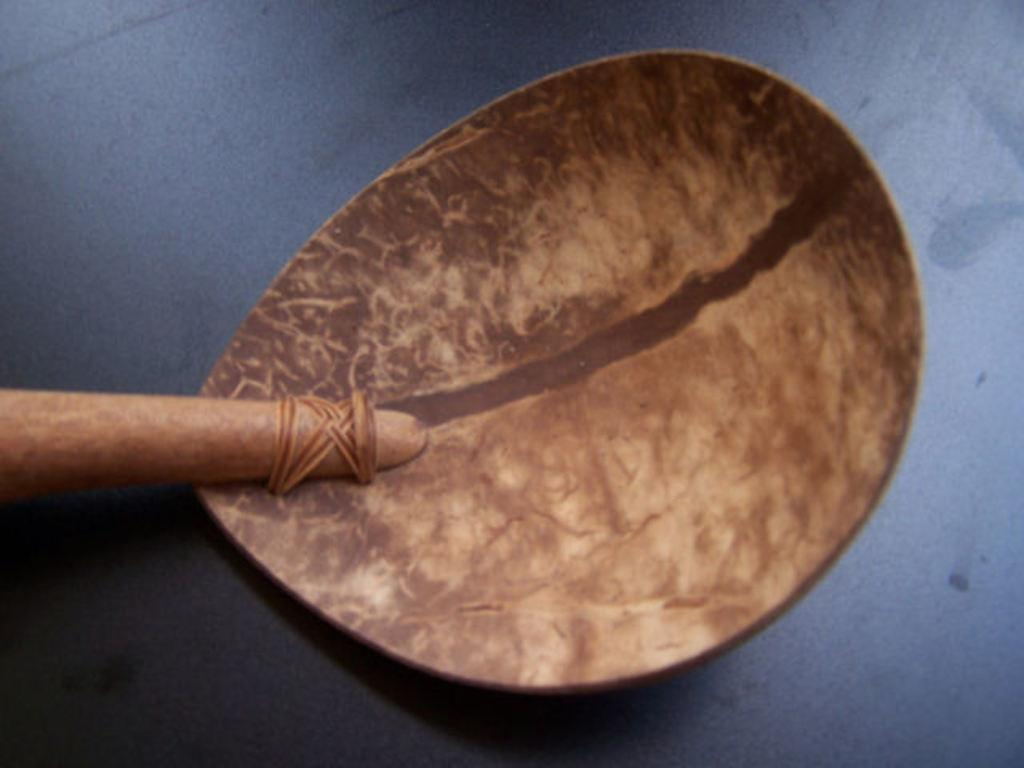What type of material is the artifact made of in the image? The wooden artifact is made of wood. Where is the wooden artifact located in the image? The wooden artifact is on the floor. What type of soup is being served in the wooden artifact in the image? There is no soup present in the image; it features a wooden artifact on the floor. What color is the pencil used to draw on the wooden artifact in the image? There is no pencil or drawing present on the wooden artifact in the image. 